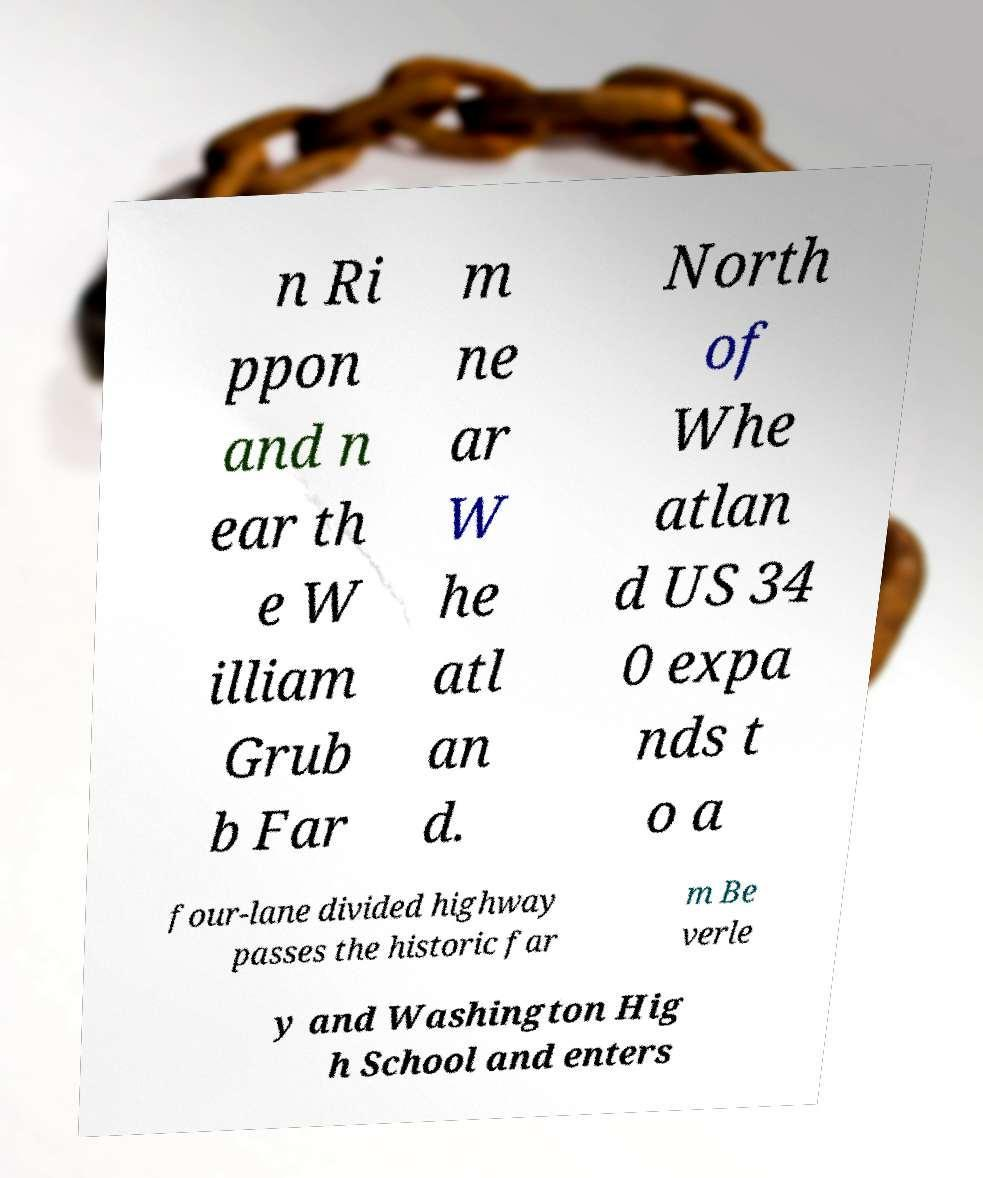Can you accurately transcribe the text from the provided image for me? n Ri ppon and n ear th e W illiam Grub b Far m ne ar W he atl an d. North of Whe atlan d US 34 0 expa nds t o a four-lane divided highway passes the historic far m Be verle y and Washington Hig h School and enters 